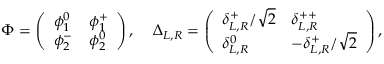Convert formula to latex. <formula><loc_0><loc_0><loc_500><loc_500>\Phi = \left ( \begin{array} { l l } { { \phi _ { 1 } ^ { 0 } } } & { { \phi _ { 1 } ^ { + } } } \\ { { \phi _ { 2 } ^ { - } } } & { { \phi _ { 2 } ^ { 0 } } } \end{array} \right ) , \, \Delta _ { L , R } = \left ( \begin{array} { l l } { { \delta _ { L , R } ^ { + } / \sqrt { 2 } } } & { { \delta _ { L , R } ^ { + + } } } \\ { { \delta _ { L , R } ^ { 0 } } } & { { - \delta _ { L , R } ^ { + } / \sqrt { 2 } } } \end{array} \right ) ,</formula> 